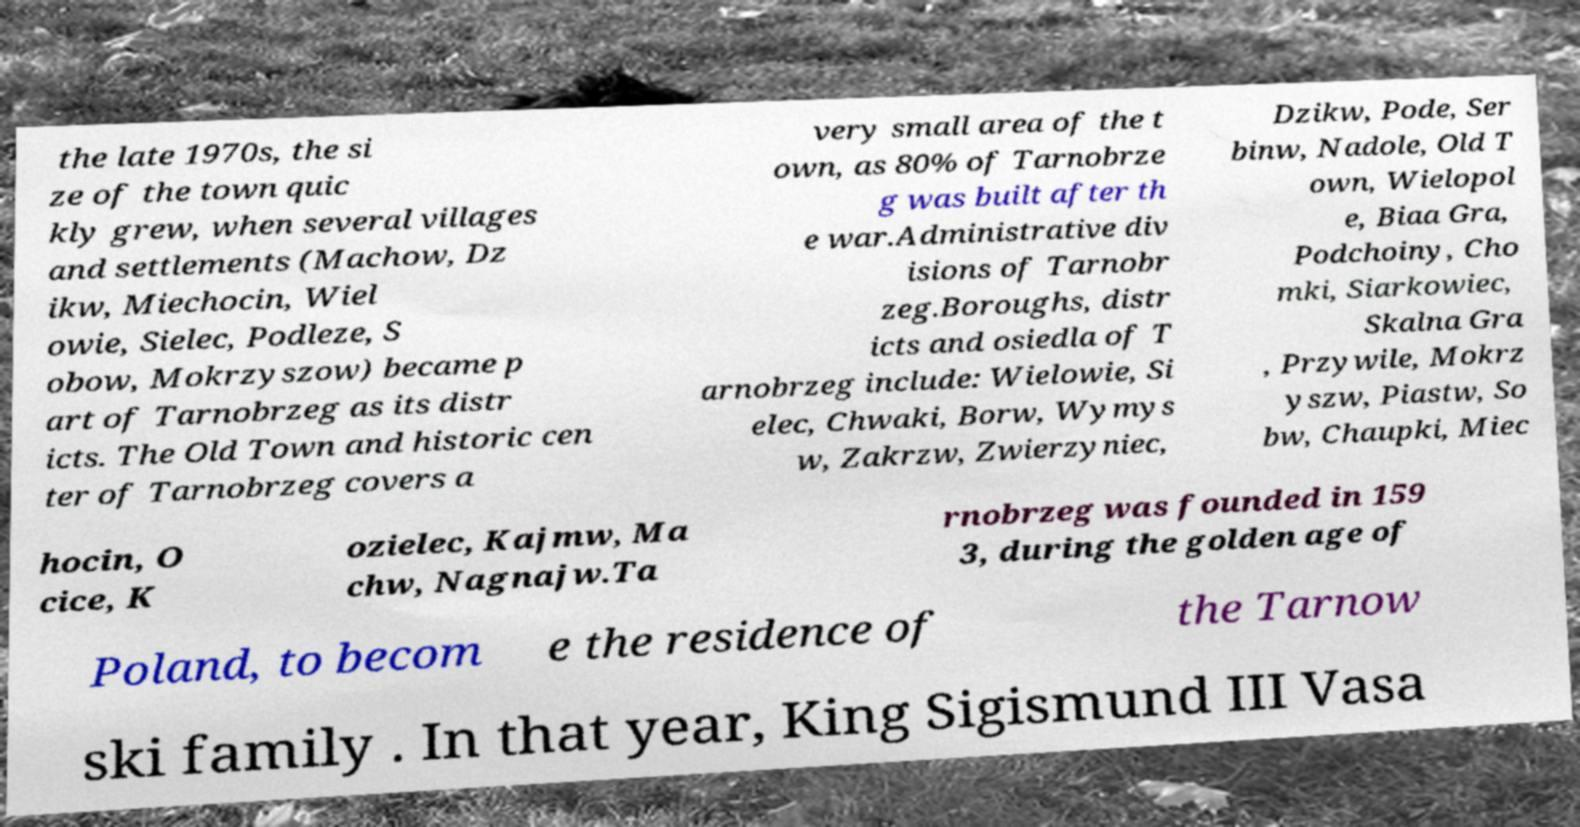Can you read and provide the text displayed in the image?This photo seems to have some interesting text. Can you extract and type it out for me? the late 1970s, the si ze of the town quic kly grew, when several villages and settlements (Machow, Dz ikw, Miechocin, Wiel owie, Sielec, Podleze, S obow, Mokrzyszow) became p art of Tarnobrzeg as its distr icts. The Old Town and historic cen ter of Tarnobrzeg covers a very small area of the t own, as 80% of Tarnobrze g was built after th e war.Administrative div isions of Tarnobr zeg.Boroughs, distr icts and osiedla of T arnobrzeg include: Wielowie, Si elec, Chwaki, Borw, Wymys w, Zakrzw, Zwierzyniec, Dzikw, Pode, Ser binw, Nadole, Old T own, Wielopol e, Biaa Gra, Podchoiny, Cho mki, Siarkowiec, Skalna Gra , Przywile, Mokrz yszw, Piastw, So bw, Chaupki, Miec hocin, O cice, K ozielec, Kajmw, Ma chw, Nagnajw.Ta rnobrzeg was founded in 159 3, during the golden age of Poland, to becom e the residence of the Tarnow ski family . In that year, King Sigismund III Vasa 